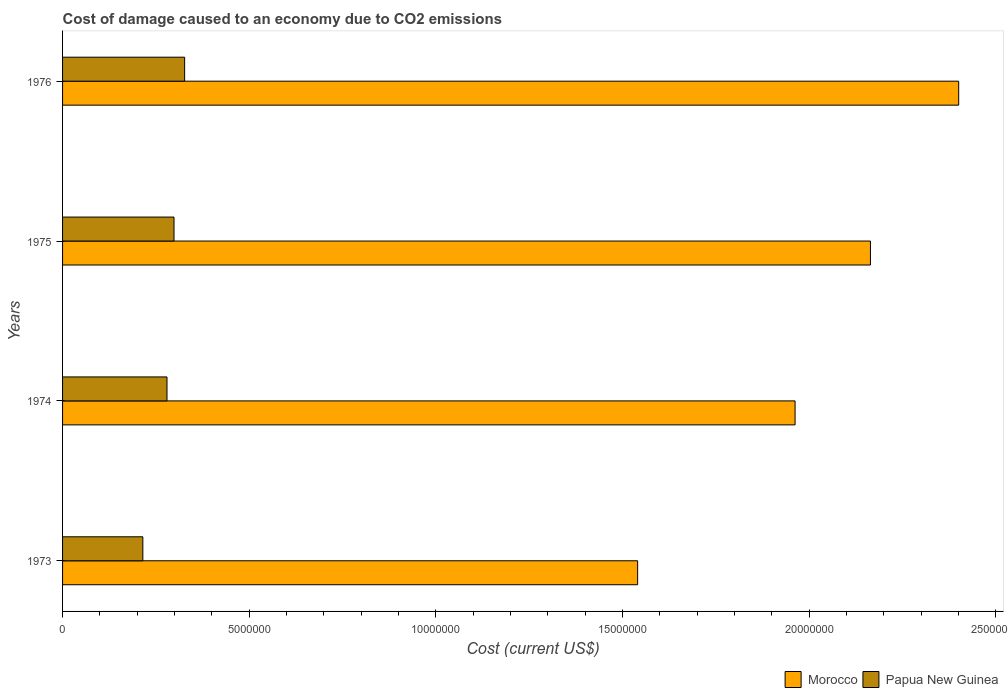How many different coloured bars are there?
Offer a very short reply. 2. How many groups of bars are there?
Provide a succinct answer. 4. What is the label of the 1st group of bars from the top?
Provide a short and direct response. 1976. What is the cost of damage caused due to CO2 emissisons in Morocco in 1973?
Provide a succinct answer. 1.54e+07. Across all years, what is the maximum cost of damage caused due to CO2 emissisons in Morocco?
Ensure brevity in your answer.  2.40e+07. Across all years, what is the minimum cost of damage caused due to CO2 emissisons in Papua New Guinea?
Ensure brevity in your answer.  2.15e+06. In which year was the cost of damage caused due to CO2 emissisons in Papua New Guinea maximum?
Ensure brevity in your answer.  1976. What is the total cost of damage caused due to CO2 emissisons in Papua New Guinea in the graph?
Your response must be concise. 1.12e+07. What is the difference between the cost of damage caused due to CO2 emissisons in Papua New Guinea in 1974 and that in 1976?
Make the answer very short. -4.73e+05. What is the difference between the cost of damage caused due to CO2 emissisons in Morocco in 1973 and the cost of damage caused due to CO2 emissisons in Papua New Guinea in 1974?
Provide a succinct answer. 1.26e+07. What is the average cost of damage caused due to CO2 emissisons in Morocco per year?
Your answer should be compact. 2.02e+07. In the year 1974, what is the difference between the cost of damage caused due to CO2 emissisons in Papua New Guinea and cost of damage caused due to CO2 emissisons in Morocco?
Give a very brief answer. -1.68e+07. In how many years, is the cost of damage caused due to CO2 emissisons in Morocco greater than 1000000 US$?
Offer a very short reply. 4. What is the ratio of the cost of damage caused due to CO2 emissisons in Morocco in 1973 to that in 1976?
Provide a short and direct response. 0.64. What is the difference between the highest and the second highest cost of damage caused due to CO2 emissisons in Papua New Guinea?
Provide a short and direct response. 2.85e+05. What is the difference between the highest and the lowest cost of damage caused due to CO2 emissisons in Morocco?
Your answer should be compact. 8.60e+06. Is the sum of the cost of damage caused due to CO2 emissisons in Papua New Guinea in 1975 and 1976 greater than the maximum cost of damage caused due to CO2 emissisons in Morocco across all years?
Your answer should be very brief. No. What does the 1st bar from the top in 1976 represents?
Keep it short and to the point. Papua New Guinea. What does the 1st bar from the bottom in 1974 represents?
Ensure brevity in your answer.  Morocco. Are all the bars in the graph horizontal?
Keep it short and to the point. Yes. Does the graph contain any zero values?
Make the answer very short. No. Does the graph contain grids?
Make the answer very short. No. Where does the legend appear in the graph?
Offer a very short reply. Bottom right. What is the title of the graph?
Ensure brevity in your answer.  Cost of damage caused to an economy due to CO2 emissions. What is the label or title of the X-axis?
Your response must be concise. Cost (current US$). What is the label or title of the Y-axis?
Provide a short and direct response. Years. What is the Cost (current US$) of Morocco in 1973?
Your response must be concise. 1.54e+07. What is the Cost (current US$) in Papua New Guinea in 1973?
Your response must be concise. 2.15e+06. What is the Cost (current US$) of Morocco in 1974?
Your answer should be compact. 1.96e+07. What is the Cost (current US$) in Papua New Guinea in 1974?
Make the answer very short. 2.80e+06. What is the Cost (current US$) of Morocco in 1975?
Offer a terse response. 2.16e+07. What is the Cost (current US$) of Papua New Guinea in 1975?
Provide a succinct answer. 2.99e+06. What is the Cost (current US$) of Morocco in 1976?
Make the answer very short. 2.40e+07. What is the Cost (current US$) in Papua New Guinea in 1976?
Give a very brief answer. 3.27e+06. Across all years, what is the maximum Cost (current US$) of Morocco?
Provide a succinct answer. 2.40e+07. Across all years, what is the maximum Cost (current US$) of Papua New Guinea?
Your answer should be compact. 3.27e+06. Across all years, what is the minimum Cost (current US$) of Morocco?
Provide a succinct answer. 1.54e+07. Across all years, what is the minimum Cost (current US$) of Papua New Guinea?
Make the answer very short. 2.15e+06. What is the total Cost (current US$) of Morocco in the graph?
Keep it short and to the point. 8.07e+07. What is the total Cost (current US$) in Papua New Guinea in the graph?
Provide a succinct answer. 1.12e+07. What is the difference between the Cost (current US$) of Morocco in 1973 and that in 1974?
Offer a terse response. -4.22e+06. What is the difference between the Cost (current US$) in Papua New Guinea in 1973 and that in 1974?
Provide a succinct answer. -6.47e+05. What is the difference between the Cost (current US$) of Morocco in 1973 and that in 1975?
Provide a succinct answer. -6.24e+06. What is the difference between the Cost (current US$) in Papua New Guinea in 1973 and that in 1975?
Provide a succinct answer. -8.35e+05. What is the difference between the Cost (current US$) of Morocco in 1973 and that in 1976?
Ensure brevity in your answer.  -8.60e+06. What is the difference between the Cost (current US$) in Papua New Guinea in 1973 and that in 1976?
Your response must be concise. -1.12e+06. What is the difference between the Cost (current US$) in Morocco in 1974 and that in 1975?
Provide a short and direct response. -2.02e+06. What is the difference between the Cost (current US$) of Papua New Guinea in 1974 and that in 1975?
Your answer should be very brief. -1.88e+05. What is the difference between the Cost (current US$) of Morocco in 1974 and that in 1976?
Your answer should be very brief. -4.38e+06. What is the difference between the Cost (current US$) of Papua New Guinea in 1974 and that in 1976?
Your response must be concise. -4.73e+05. What is the difference between the Cost (current US$) in Morocco in 1975 and that in 1976?
Your response must be concise. -2.36e+06. What is the difference between the Cost (current US$) of Papua New Guinea in 1975 and that in 1976?
Ensure brevity in your answer.  -2.85e+05. What is the difference between the Cost (current US$) in Morocco in 1973 and the Cost (current US$) in Papua New Guinea in 1974?
Give a very brief answer. 1.26e+07. What is the difference between the Cost (current US$) in Morocco in 1973 and the Cost (current US$) in Papua New Guinea in 1975?
Give a very brief answer. 1.24e+07. What is the difference between the Cost (current US$) of Morocco in 1973 and the Cost (current US$) of Papua New Guinea in 1976?
Provide a succinct answer. 1.21e+07. What is the difference between the Cost (current US$) in Morocco in 1974 and the Cost (current US$) in Papua New Guinea in 1975?
Give a very brief answer. 1.66e+07. What is the difference between the Cost (current US$) in Morocco in 1974 and the Cost (current US$) in Papua New Guinea in 1976?
Give a very brief answer. 1.64e+07. What is the difference between the Cost (current US$) in Morocco in 1975 and the Cost (current US$) in Papua New Guinea in 1976?
Your answer should be compact. 1.84e+07. What is the average Cost (current US$) in Morocco per year?
Ensure brevity in your answer.  2.02e+07. What is the average Cost (current US$) of Papua New Guinea per year?
Provide a short and direct response. 2.80e+06. In the year 1973, what is the difference between the Cost (current US$) of Morocco and Cost (current US$) of Papua New Guinea?
Your answer should be very brief. 1.33e+07. In the year 1974, what is the difference between the Cost (current US$) of Morocco and Cost (current US$) of Papua New Guinea?
Make the answer very short. 1.68e+07. In the year 1975, what is the difference between the Cost (current US$) of Morocco and Cost (current US$) of Papua New Guinea?
Your response must be concise. 1.87e+07. In the year 1976, what is the difference between the Cost (current US$) in Morocco and Cost (current US$) in Papua New Guinea?
Your response must be concise. 2.07e+07. What is the ratio of the Cost (current US$) of Morocco in 1973 to that in 1974?
Your answer should be very brief. 0.79. What is the ratio of the Cost (current US$) of Papua New Guinea in 1973 to that in 1974?
Provide a succinct answer. 0.77. What is the ratio of the Cost (current US$) in Morocco in 1973 to that in 1975?
Provide a short and direct response. 0.71. What is the ratio of the Cost (current US$) of Papua New Guinea in 1973 to that in 1975?
Your response must be concise. 0.72. What is the ratio of the Cost (current US$) in Morocco in 1973 to that in 1976?
Give a very brief answer. 0.64. What is the ratio of the Cost (current US$) of Papua New Guinea in 1973 to that in 1976?
Ensure brevity in your answer.  0.66. What is the ratio of the Cost (current US$) in Morocco in 1974 to that in 1975?
Give a very brief answer. 0.91. What is the ratio of the Cost (current US$) in Papua New Guinea in 1974 to that in 1975?
Provide a succinct answer. 0.94. What is the ratio of the Cost (current US$) in Morocco in 1974 to that in 1976?
Offer a terse response. 0.82. What is the ratio of the Cost (current US$) of Papua New Guinea in 1974 to that in 1976?
Provide a short and direct response. 0.86. What is the ratio of the Cost (current US$) of Morocco in 1975 to that in 1976?
Your answer should be very brief. 0.9. What is the ratio of the Cost (current US$) of Papua New Guinea in 1975 to that in 1976?
Offer a terse response. 0.91. What is the difference between the highest and the second highest Cost (current US$) of Morocco?
Keep it short and to the point. 2.36e+06. What is the difference between the highest and the second highest Cost (current US$) in Papua New Guinea?
Offer a very short reply. 2.85e+05. What is the difference between the highest and the lowest Cost (current US$) of Morocco?
Your answer should be compact. 8.60e+06. What is the difference between the highest and the lowest Cost (current US$) in Papua New Guinea?
Your answer should be very brief. 1.12e+06. 